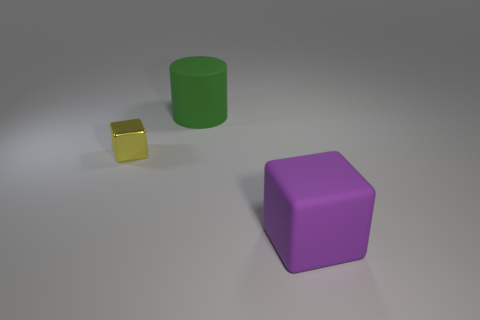Add 1 small yellow metal cylinders. How many objects exist? 4 Subtract all yellow blocks. How many blocks are left? 1 Subtract all gray blocks. Subtract all blue spheres. How many blocks are left? 2 Subtract all green cylinders. How many yellow blocks are left? 1 Subtract all big red shiny objects. Subtract all yellow objects. How many objects are left? 2 Add 2 green cylinders. How many green cylinders are left? 3 Add 3 big gray metallic cylinders. How many big gray metallic cylinders exist? 3 Subtract 0 red spheres. How many objects are left? 3 Subtract all cubes. How many objects are left? 1 Subtract 2 cubes. How many cubes are left? 0 